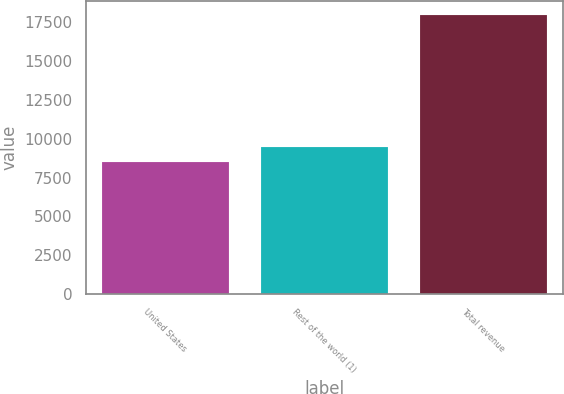Convert chart. <chart><loc_0><loc_0><loc_500><loc_500><bar_chart><fcel>United States<fcel>Rest of the world (1)<fcel>Total revenue<nl><fcel>8513<fcel>9454.5<fcel>17928<nl></chart> 